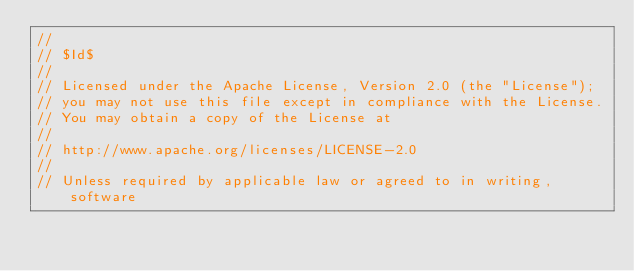Convert code to text. <code><loc_0><loc_0><loc_500><loc_500><_C_>//
// $Id$
//
// Licensed under the Apache License, Version 2.0 (the "License"); 
// you may not use this file except in compliance with the License. 
// You may obtain a copy of the License at 
//
// http://www.apache.org/licenses/LICENSE-2.0
//
// Unless required by applicable law or agreed to in writing, software </code> 